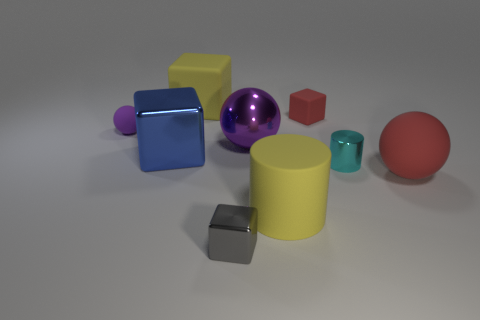What shape is the small gray object that is made of the same material as the big blue block?
Your answer should be very brief. Cube. Is there anything else that is the same shape as the big purple metallic thing?
Give a very brief answer. Yes. There is a tiny matte ball; how many purple rubber spheres are to the left of it?
Your response must be concise. 0. Are there an equal number of tiny gray metallic blocks that are behind the large metal block and blue metallic things?
Offer a very short reply. No. Are the small purple sphere and the tiny cyan cylinder made of the same material?
Offer a terse response. No. There is a sphere that is on the right side of the gray object and behind the small cylinder; how big is it?
Give a very brief answer. Large. How many matte things have the same size as the red block?
Ensure brevity in your answer.  1. Are there an equal number of red blocks and large red cylinders?
Offer a very short reply. No. What is the size of the yellow matte object that is in front of the red matte object on the right side of the small red object?
Your response must be concise. Large. Do the red thing that is behind the small cyan metallic thing and the small shiny object that is in front of the matte cylinder have the same shape?
Your answer should be very brief. Yes. 